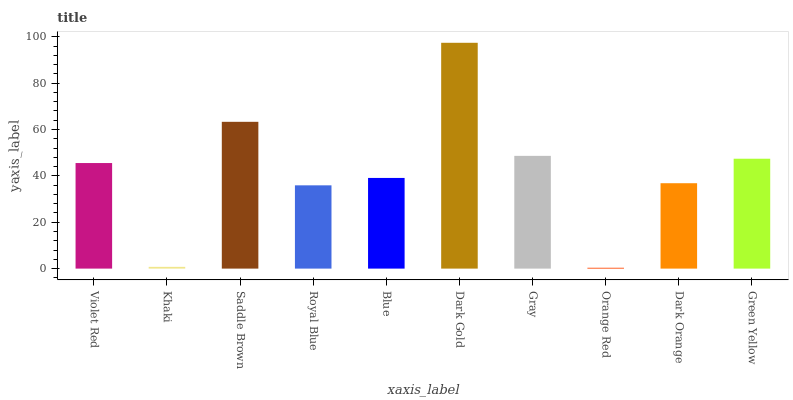Is Orange Red the minimum?
Answer yes or no. Yes. Is Dark Gold the maximum?
Answer yes or no. Yes. Is Khaki the minimum?
Answer yes or no. No. Is Khaki the maximum?
Answer yes or no. No. Is Violet Red greater than Khaki?
Answer yes or no. Yes. Is Khaki less than Violet Red?
Answer yes or no. Yes. Is Khaki greater than Violet Red?
Answer yes or no. No. Is Violet Red less than Khaki?
Answer yes or no. No. Is Violet Red the high median?
Answer yes or no. Yes. Is Blue the low median?
Answer yes or no. Yes. Is Blue the high median?
Answer yes or no. No. Is Royal Blue the low median?
Answer yes or no. No. 